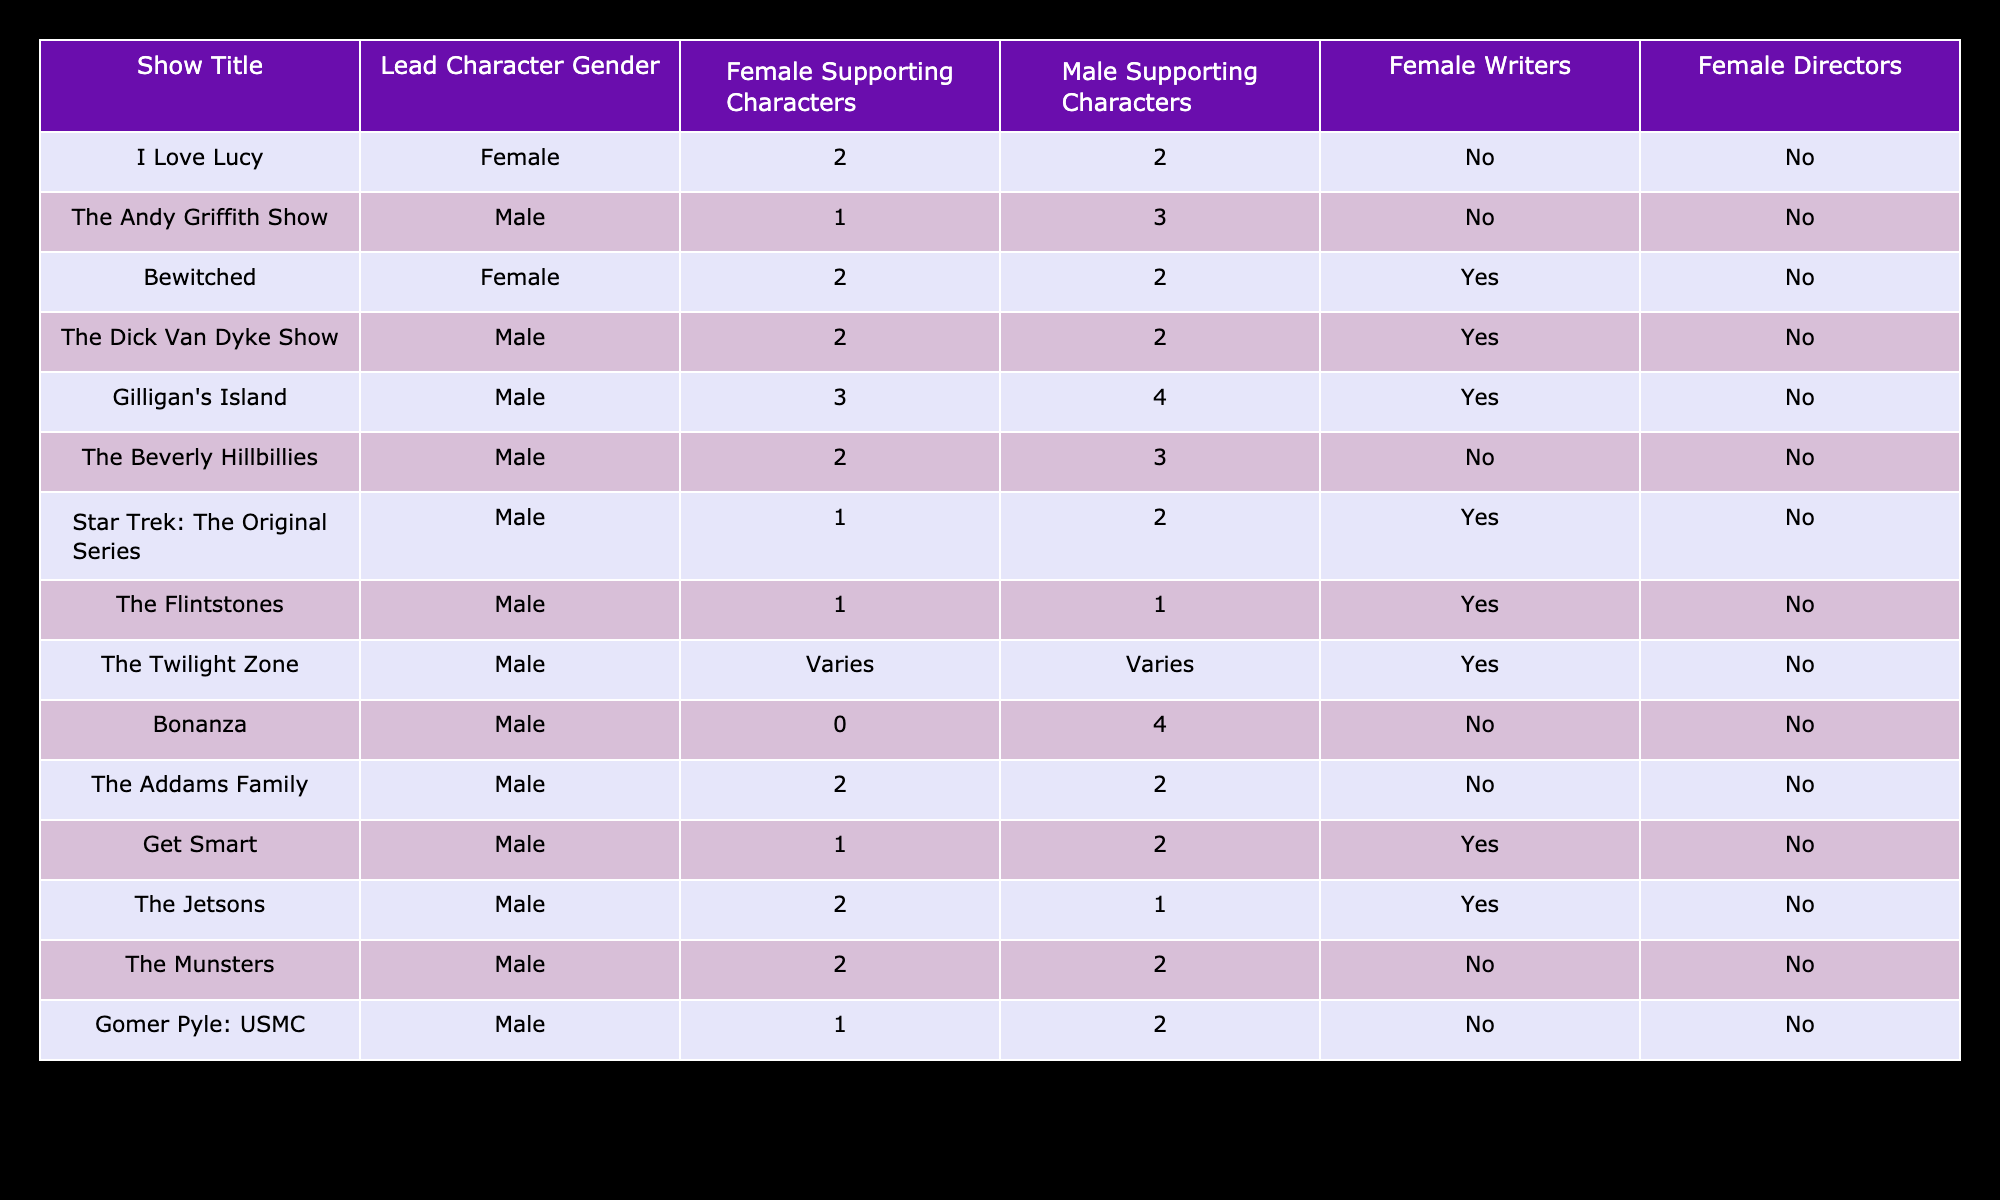What is the lead character gender of 'Gilligan's Island'? The table indicates that 'Gilligan's Island' has a male lead character in the corresponding column titled 'Lead Character Gender'.
Answer: Male How many female supporting characters are in 'Bewitched'? According to the table, 'Bewitched' has 2 female supporting characters listed under the column 'Female Supporting Characters'.
Answer: 2 Which show has the highest number of male supporting characters? By reviewing the column 'Male Supporting Characters', 'Bonanza' shows 4 male supporting characters, which is the maximum compared to other shows in that column.
Answer: Bonanza Are there any shows that had female writers? The table displays 'Bewitched', 'The Dick Van Dyke Show', 'Gilligan's Island', 'Star Trek: The Original Series', and 'Get Smart' with 'Yes' in the column 'Female Writers'; thus there are multiple shows with female writers.
Answer: Yes What is the total number of female supporting characters across all shows listed? First, we add the number of female supporting characters from each row: 2 + 1 + 2 + 2 + 3 + 2 + 1 + 1 + Varies + 0 + 2 + 1 + 2 + 1 = 19 (not including 'Varies' since it does not provide a specific number). Therefore, the total number is 19.
Answer: 19 Which show or shows had the least number of female supporting characters? By examining the 'Female Supporting Characters' column, both 'Bonanza' and 'The Andy Griffith Show' each have 1 female supporting character, which is the lowest count in that column.
Answer: Bonanza and The Andy Griffith Show What percentage of shows had female directors? There are 15 shows total, and only 0 of these have female directors. Thus, the percentage is (0/15) * 100% = 0%.
Answer: 0% If there are 4 shows with a female lead, how many more shows have a male lead? There are 15 total shows. If 4 shows have a female lead, that leaves 15 - 4 = 11 shows with male leads.
Answer: 11 How many shows feature male characters significantly as supporting characters compared to female characters? By counting the male and female supporting characters: Total male supporting characters = 20, Total female supporting characters = 19. Thus, 20 > 19 indicates more male significantly present than female.
Answer: Yes 